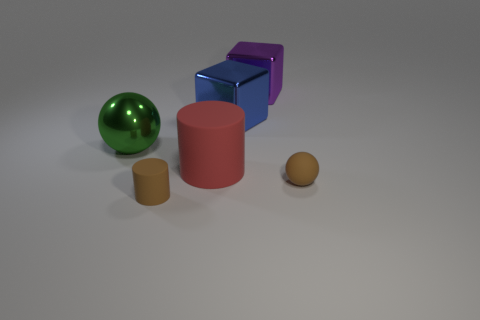Add 3 large green matte things. How many objects exist? 9 Subtract all blocks. How many objects are left? 4 Subtract 0 yellow balls. How many objects are left? 6 Subtract all green blocks. Subtract all green spheres. How many blocks are left? 2 Subtract all tiny cylinders. Subtract all rubber cylinders. How many objects are left? 3 Add 2 large purple things. How many large purple things are left? 3 Add 6 purple metal objects. How many purple metal objects exist? 7 